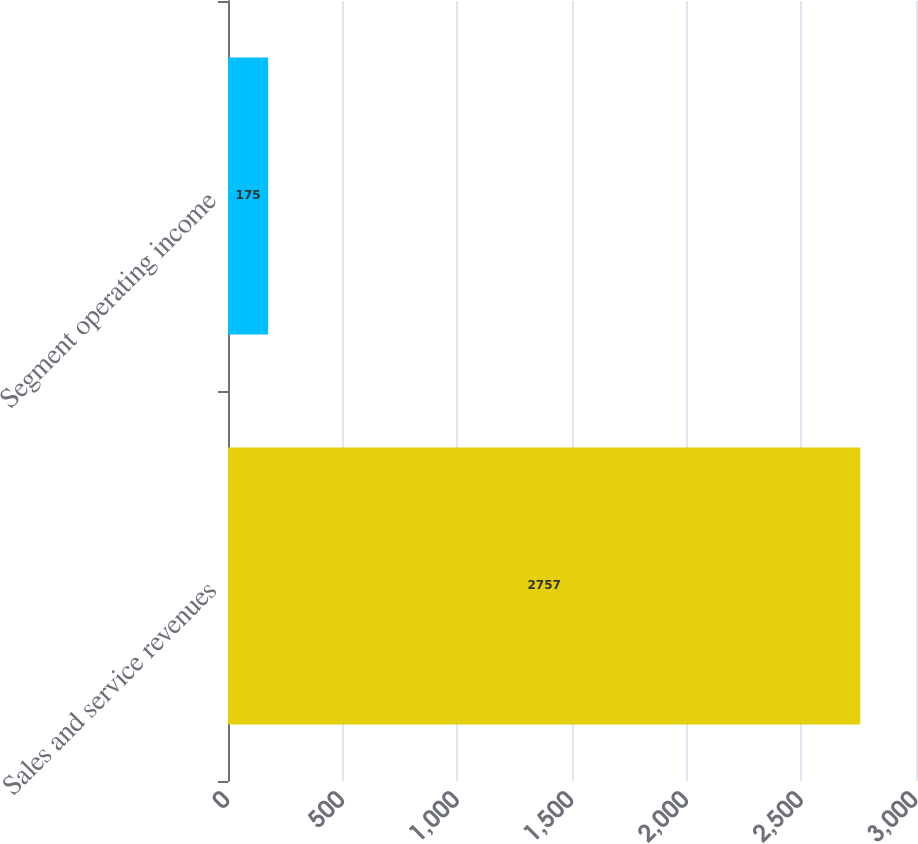Convert chart. <chart><loc_0><loc_0><loc_500><loc_500><bar_chart><fcel>Sales and service revenues<fcel>Segment operating income<nl><fcel>2757<fcel>175<nl></chart> 